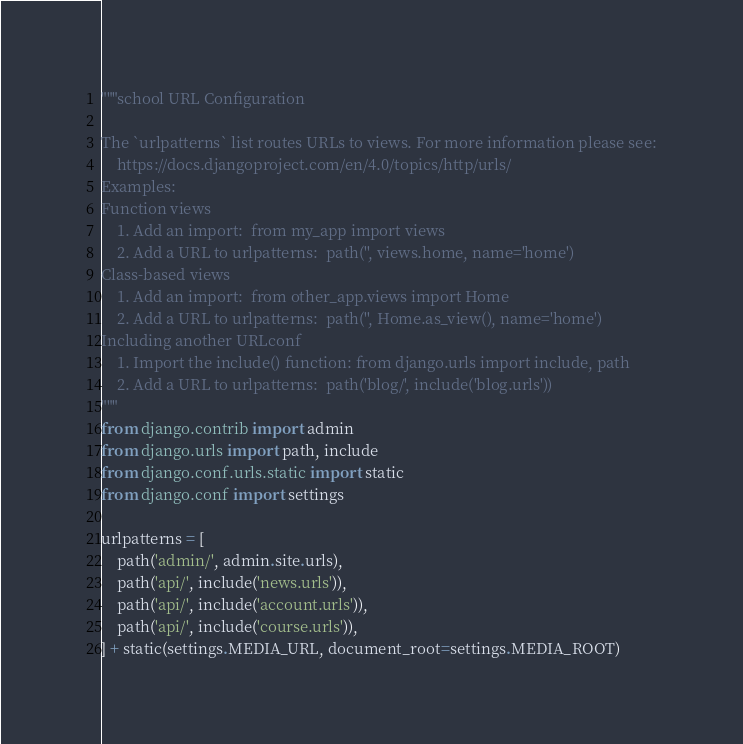<code> <loc_0><loc_0><loc_500><loc_500><_Python_>"""school URL Configuration

The `urlpatterns` list routes URLs to views. For more information please see:
    https://docs.djangoproject.com/en/4.0/topics/http/urls/
Examples:
Function views
    1. Add an import:  from my_app import views
    2. Add a URL to urlpatterns:  path('', views.home, name='home')
Class-based views
    1. Add an import:  from other_app.views import Home
    2. Add a URL to urlpatterns:  path('', Home.as_view(), name='home')
Including another URLconf
    1. Import the include() function: from django.urls import include, path
    2. Add a URL to urlpatterns:  path('blog/', include('blog.urls'))
"""
from django.contrib import admin
from django.urls import path, include
from django.conf.urls.static import static
from django.conf import settings

urlpatterns = [
    path('admin/', admin.site.urls),
    path('api/', include('news.urls')),
    path('api/', include('account.urls')),
    path('api/', include('course.urls')),
] + static(settings.MEDIA_URL, document_root=settings.MEDIA_ROOT)
</code> 